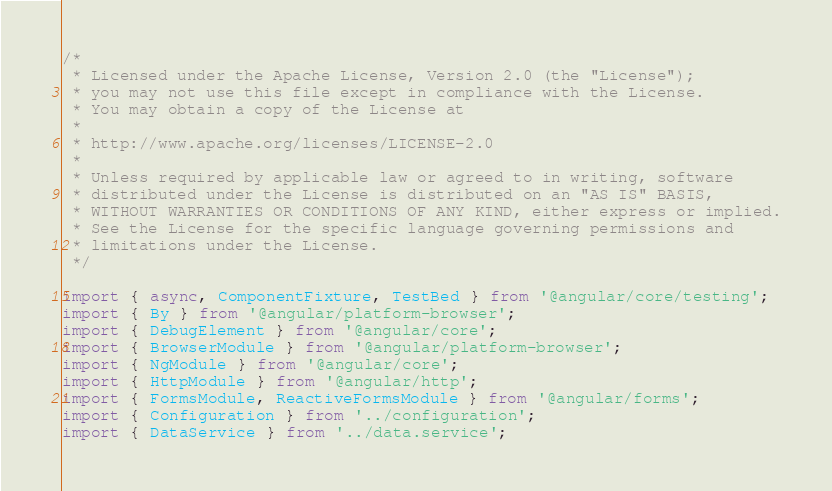Convert code to text. <code><loc_0><loc_0><loc_500><loc_500><_TypeScript_>/*
 * Licensed under the Apache License, Version 2.0 (the "License");
 * you may not use this file except in compliance with the License.
 * You may obtain a copy of the License at
 *
 * http://www.apache.org/licenses/LICENSE-2.0
 *
 * Unless required by applicable law or agreed to in writing, software
 * distributed under the License is distributed on an "AS IS" BASIS,
 * WITHOUT WARRANTIES OR CONDITIONS OF ANY KIND, either express or implied.
 * See the License for the specific language governing permissions and
 * limitations under the License.
 */

import { async, ComponentFixture, TestBed } from '@angular/core/testing';
import { By } from '@angular/platform-browser';
import { DebugElement } from '@angular/core';
import { BrowserModule } from '@angular/platform-browser';
import { NgModule } from '@angular/core';
import { HttpModule } from '@angular/http';
import { FormsModule, ReactiveFormsModule } from '@angular/forms';
import { Configuration } from '../configuration';
import { DataService } from '../data.service';</code> 